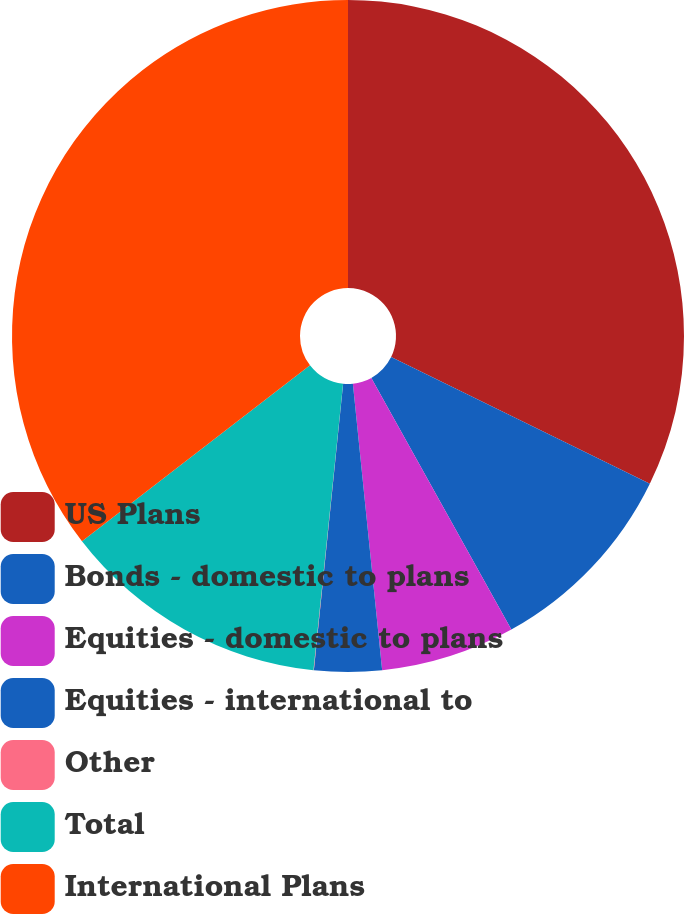Convert chart to OTSL. <chart><loc_0><loc_0><loc_500><loc_500><pie_chart><fcel>US Plans<fcel>Bonds - domestic to plans<fcel>Equities - domestic to plans<fcel>Equities - international to<fcel>Other<fcel>Total<fcel>International Plans<nl><fcel>32.24%<fcel>9.68%<fcel>6.46%<fcel>3.24%<fcel>0.02%<fcel>12.9%<fcel>35.46%<nl></chart> 